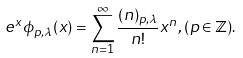Convert formula to latex. <formula><loc_0><loc_0><loc_500><loc_500>e ^ { x } \phi _ { p , \lambda } ( x ) = \sum _ { n = 1 } ^ { \infty } \frac { ( n ) _ { p , \lambda } } { n ! } x ^ { n } , ( p \in \mathbb { Z } ) .</formula> 